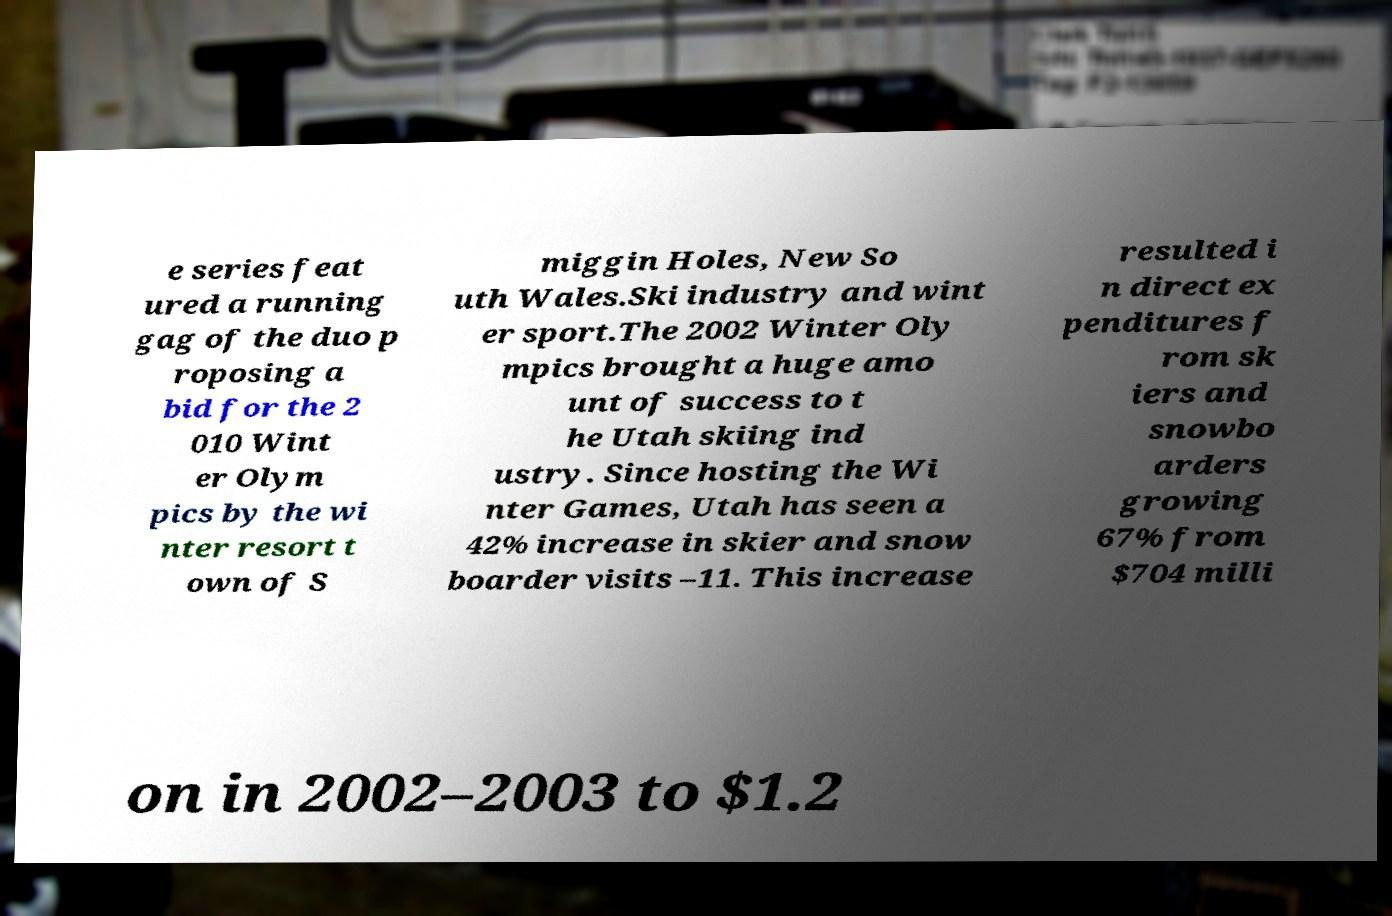Could you extract and type out the text from this image? e series feat ured a running gag of the duo p roposing a bid for the 2 010 Wint er Olym pics by the wi nter resort t own of S miggin Holes, New So uth Wales.Ski industry and wint er sport.The 2002 Winter Oly mpics brought a huge amo unt of success to t he Utah skiing ind ustry. Since hosting the Wi nter Games, Utah has seen a 42% increase in skier and snow boarder visits –11. This increase resulted i n direct ex penditures f rom sk iers and snowbo arders growing 67% from $704 milli on in 2002–2003 to $1.2 